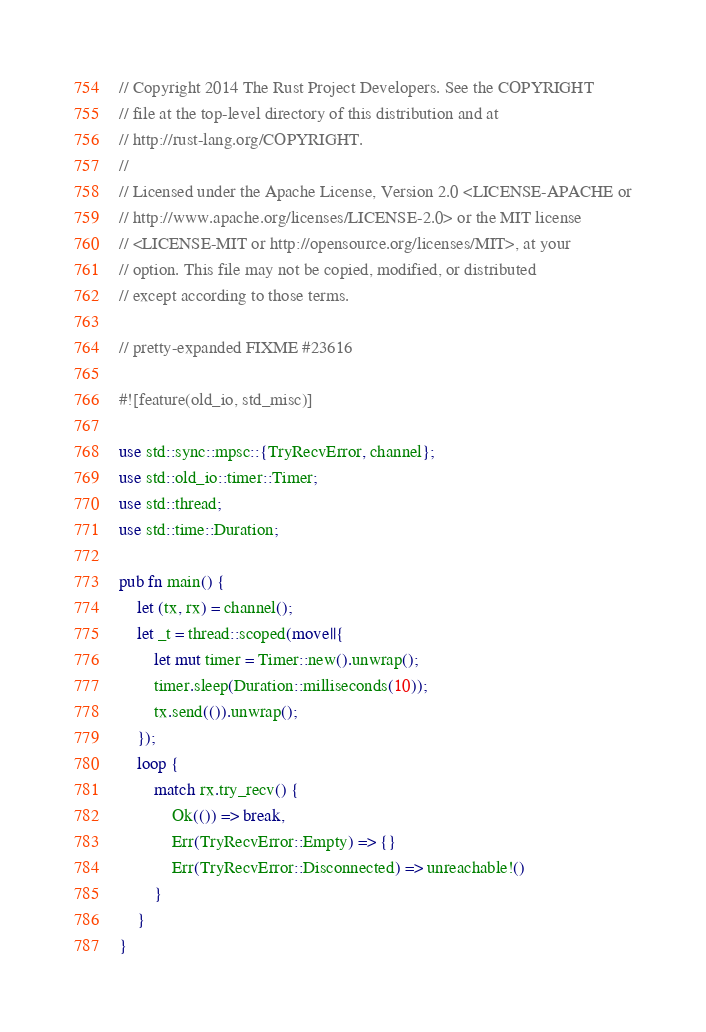Convert code to text. <code><loc_0><loc_0><loc_500><loc_500><_Rust_>// Copyright 2014 The Rust Project Developers. See the COPYRIGHT
// file at the top-level directory of this distribution and at
// http://rust-lang.org/COPYRIGHT.
//
// Licensed under the Apache License, Version 2.0 <LICENSE-APACHE or
// http://www.apache.org/licenses/LICENSE-2.0> or the MIT license
// <LICENSE-MIT or http://opensource.org/licenses/MIT>, at your
// option. This file may not be copied, modified, or distributed
// except according to those terms.

// pretty-expanded FIXME #23616

#![feature(old_io, std_misc)]

use std::sync::mpsc::{TryRecvError, channel};
use std::old_io::timer::Timer;
use std::thread;
use std::time::Duration;

pub fn main() {
    let (tx, rx) = channel();
    let _t = thread::scoped(move||{
        let mut timer = Timer::new().unwrap();
        timer.sleep(Duration::milliseconds(10));
        tx.send(()).unwrap();
    });
    loop {
        match rx.try_recv() {
            Ok(()) => break,
            Err(TryRecvError::Empty) => {}
            Err(TryRecvError::Disconnected) => unreachable!()
        }
    }
}
</code> 